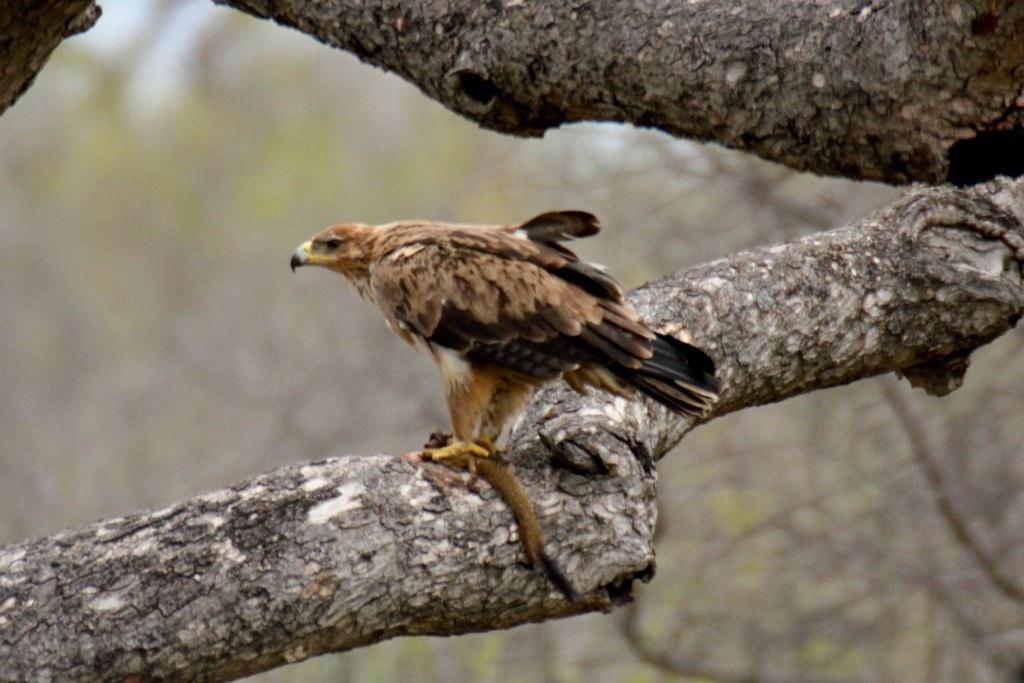How would you summarize this image in a sentence or two? In this image I can see a bird visible on the stem of tree 